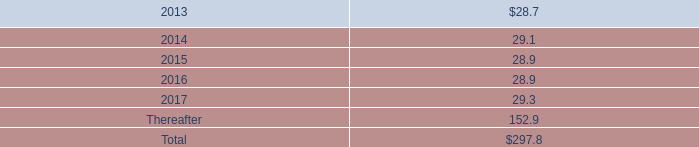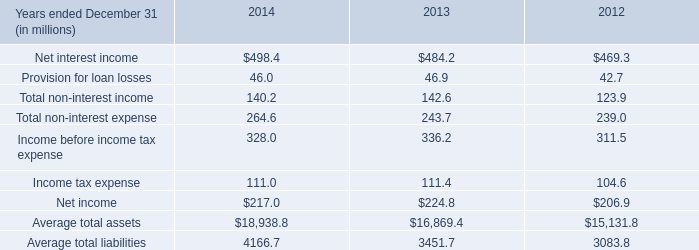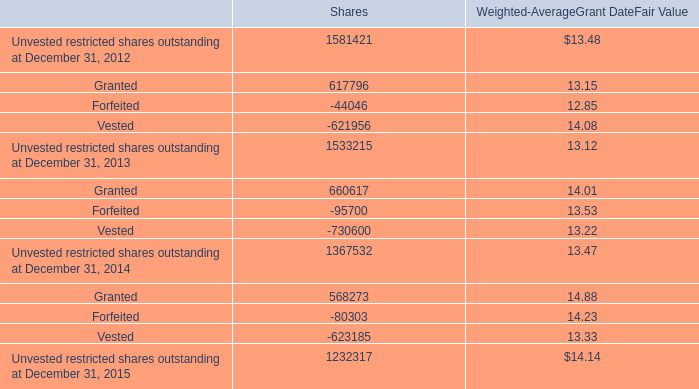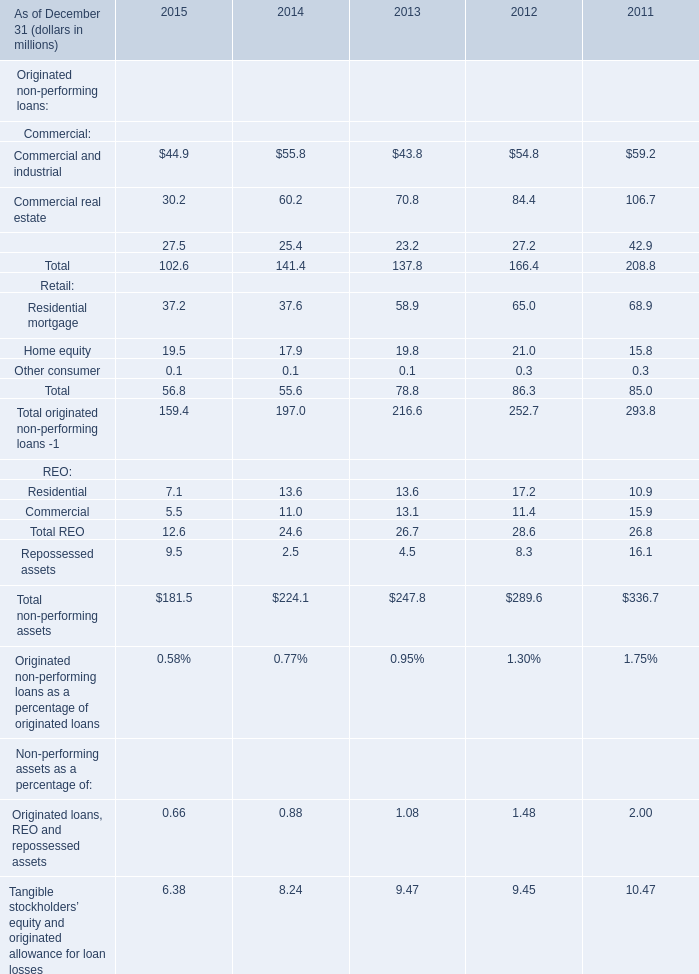what was the ratio of the assets to the obligations of the mrrp in 2012 
Computations: (18.4 / 22.7)
Answer: 0.81057. 